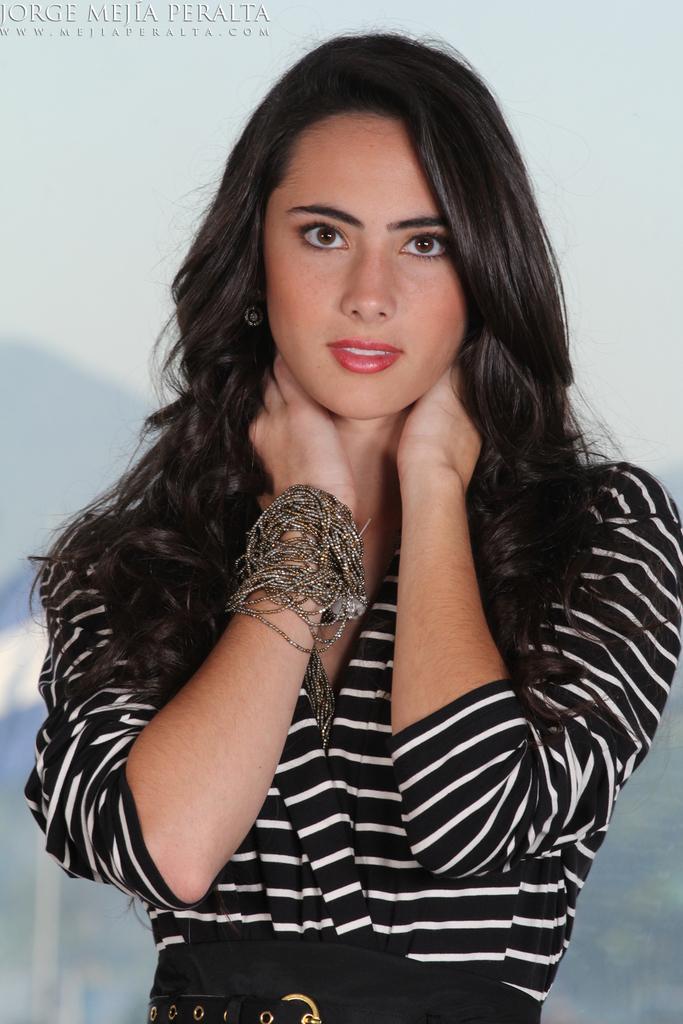Can you describe this image briefly? In this picture, we see the woman in the black dress is stunning. She is smiling. She is wearing a bracelet or the bands. She is posing for the photo. In the background, it is in white and blue color. 